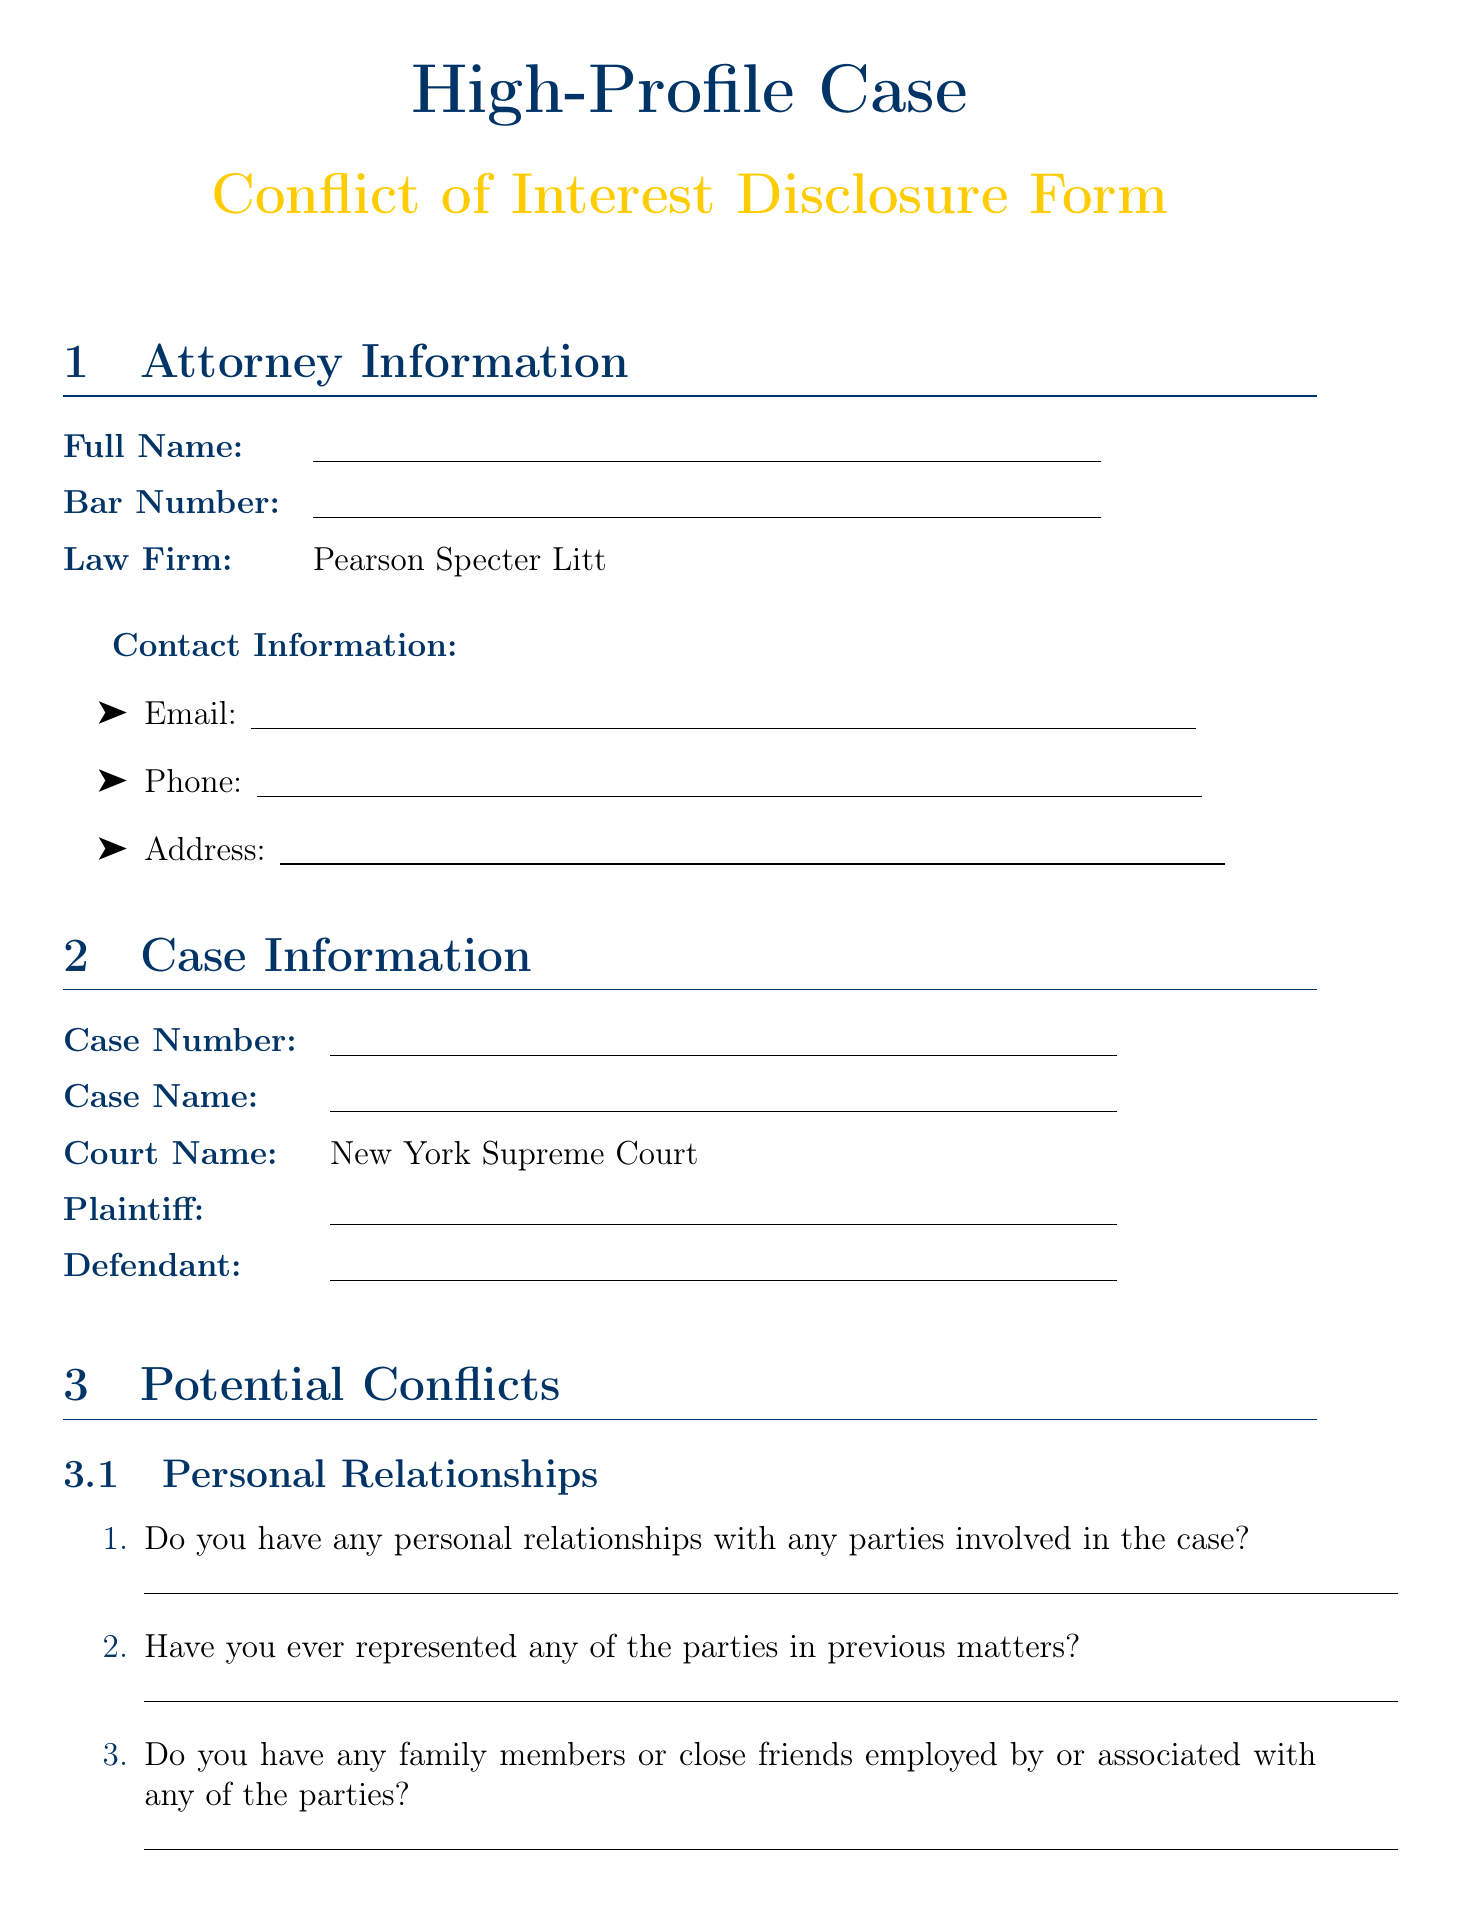What is the law firm associated with the attorney? The law firm listed in the document is Pearson Specter Litt.
Answer: Pearson Specter Litt What is the court name where the case is being heard? The court mentioned in the document is the New York Supreme Court.
Answer: New York Supreme Court What are the names of two opposing counsel firms listed? The document provides a list of opposing counsel firms; two of them are Skadden, Arps, Slate, Meagher & Flom LLP and Latham & Watkins LLP.
Answer: Skadden, Arps, Slate, Meagher & Flom LLP; Latham & Watkins LLP How many questions are in the Media Exposure section? The Media Exposure section contains four questions to disclose potential media exposure.
Answer: Four What is the confidentiality agreement about? The confidentiality agreement states that the provided information is confidential and should be updated promptly if necessary.
Answer: Confidential information usage Have you ever represented any of the parties in previous matters? This question specifically addresses a potential conflict of interest related to prior representation.
Answer: Conflict of interest question What should the attorney acknowledge in the Ethical Considerations section? The attorney commits to upholding the principles of client confidentiality, avoiding conflicts, and ensuring fair representation.
Answer: Ethical commitments Which media outlets are mentioned in the document? The document lists multiple media outlets, including CNN, The New York Times, and Wall Street Journal.
Answer: CNN, The New York Times, Wall Street Journal, Bloomberg, Reuters 